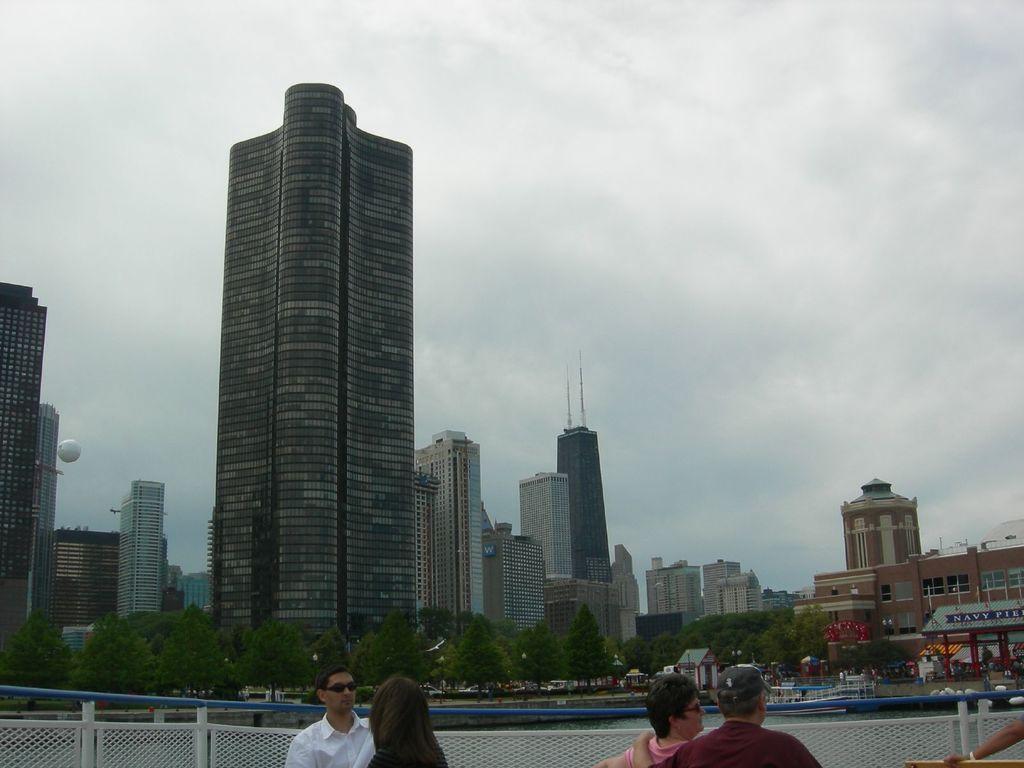How would you summarize this image in a sentence or two? In this image we can see a group of buildings, a balloon, some houses, a group of trees, a signboard and the sky which looks cloudy. On the bottom of the image we can see a water body and a group of people standing beside a fence. 